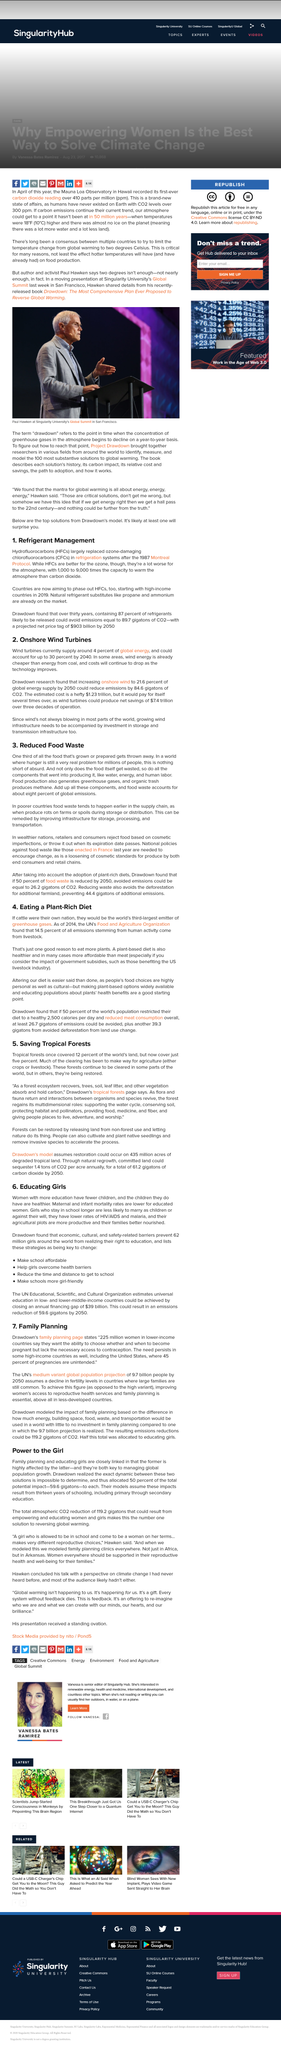Outline some significant characteristics in this image. Women who have fewer children and whose children are healthier tend to have more education. Propane is a natural refrigerant substitute that is commonly used in place of traditional refrigerants due to its efficiency and environmental benefits. The key to managing global population growth is family planning and educating girls. Flora and fauna are prevalent in the natural world and encompass the categories of plants and animals, respectively. The maternal and infant mortality rates are lower for educated women compared to those who are less educated. 